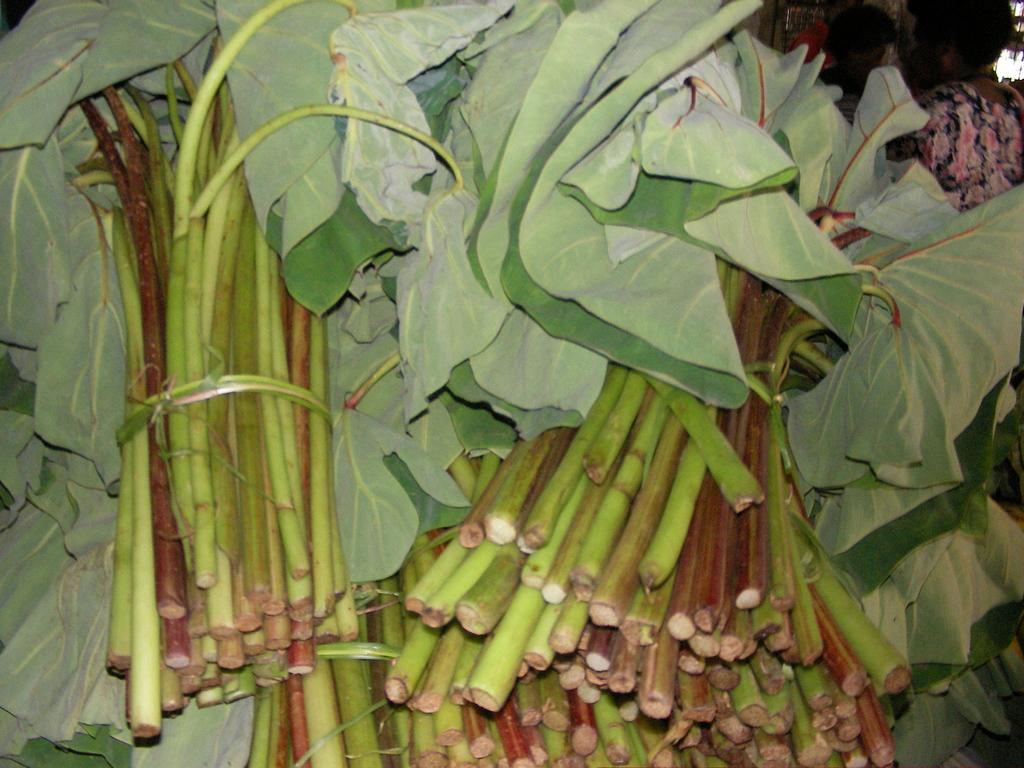What is present in the image that resembles vegetation? There are bunches of leaves in the image. Can you describe the people in the image? There are persons in the image, specifically at the right top. What type of net can be seen in the image? There is no net present in the image. What is the voice of the person in the image? The image is static, so there is no voice or sound associated with it. 